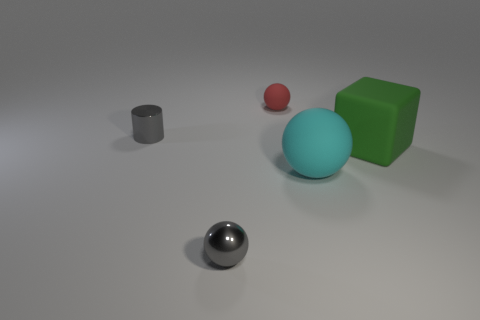Add 3 small red rubber things. How many objects exist? 8 Subtract all balls. How many objects are left? 2 Subtract 0 green cylinders. How many objects are left? 5 Subtract all large blue metal balls. Subtract all tiny gray shiny objects. How many objects are left? 3 Add 5 small gray metallic cylinders. How many small gray metallic cylinders are left? 6 Add 4 cyan matte spheres. How many cyan matte spheres exist? 5 